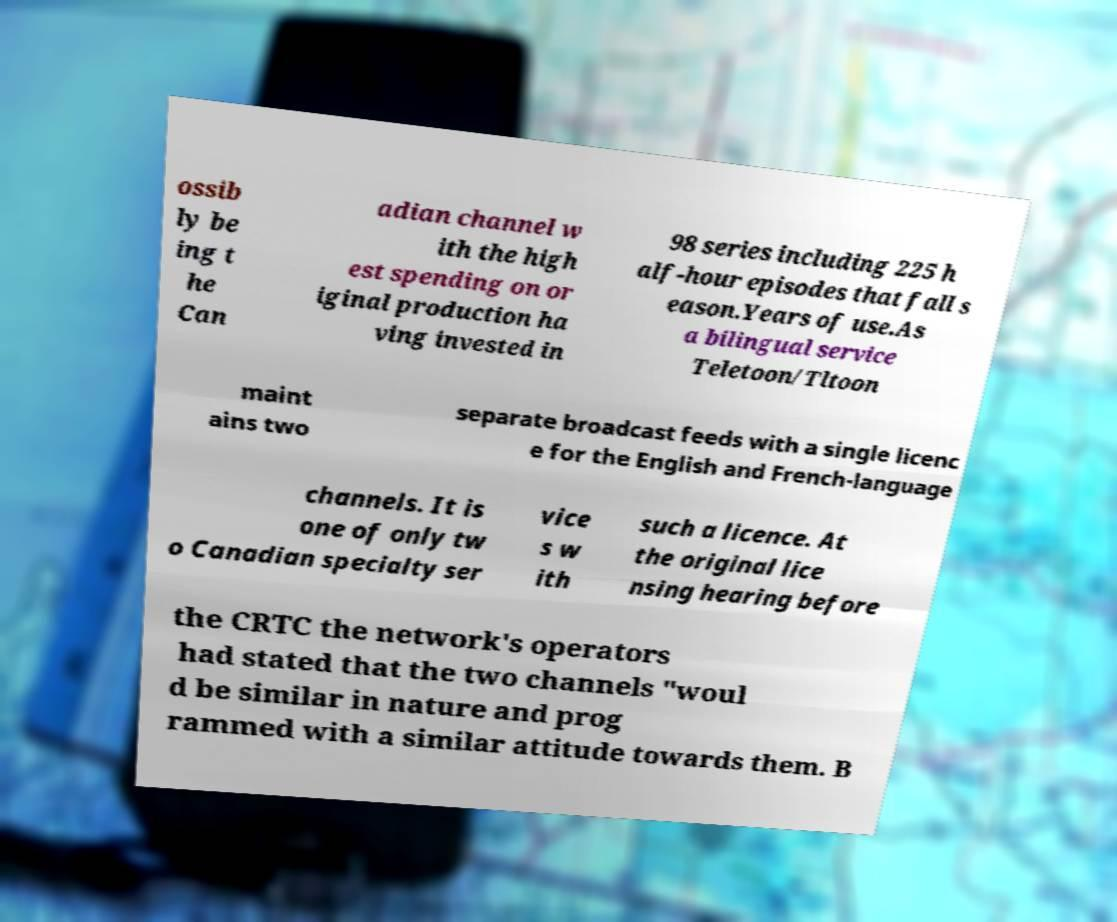Please read and relay the text visible in this image. What does it say? ossib ly be ing t he Can adian channel w ith the high est spending on or iginal production ha ving invested in 98 series including 225 h alf-hour episodes that fall s eason.Years of use.As a bilingual service Teletoon/Tltoon maint ains two separate broadcast feeds with a single licenc e for the English and French-language channels. It is one of only tw o Canadian specialty ser vice s w ith such a licence. At the original lice nsing hearing before the CRTC the network's operators had stated that the two channels "woul d be similar in nature and prog rammed with a similar attitude towards them. B 